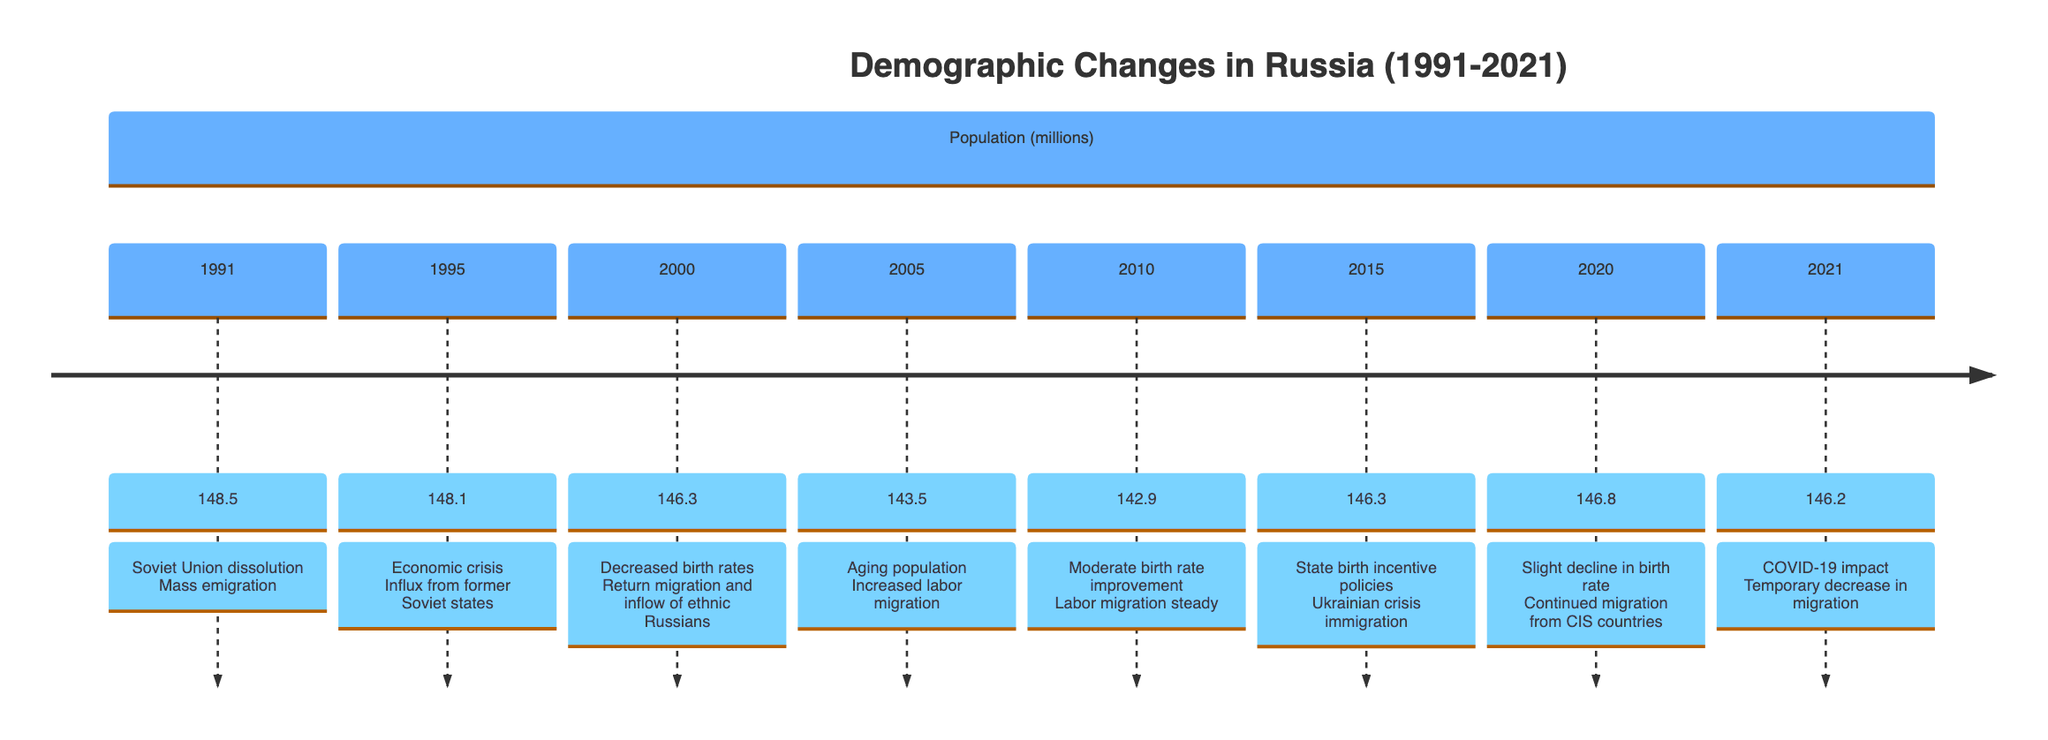What was the population of Russia in 1991? According to the diagram, the population of Russia in 1991 was marked at 148.5 million.
Answer: 148.5 million What significant event occurred in 1995? The diagram states that in 1995, the salient event was an economic crisis which led to an influx from former Soviet states, indicated alongside the population figure.
Answer: Economic crisis What was the population in 2005? The specific value listed for the population in 2005 is 143.5 million, as shown in the diagram.
Answer: 143.5 million How did the population change from 2000 to 2010? The population decreased from 146.3 million in 2000 to 142.9 million in 2010, indicating a decline over that decade. Calculating the difference shows a total decrease of 3.4 million.
Answer: Decreased by 3.4 million What were the population levels in 2015 and 2020? In 2015 the population was 146.3 million and in 2020 it rose slightly to 146.8 million, according to the respective points on the diagram.
Answer: 146.3 million and 146.8 million What was the effect of COVID-19 on migration in 2021? The diagram illustrates that in 2021, COVID-19 had an impact leading to a temporary decrease in migration, emphasizing a direct effect on demographic patterns that year.
Answer: Temporary decrease How did migration patterns change from 1995 to 2021? The diagram indicates a fluctuation in migration, with notable influx from former Soviet states in 1995, steady labor migration until 2010, an increase due to the Ukrainian crisis in 2015, and finally a temporary decrease in 2021 due to COVID-19. This overview indicates both growth and decline phases.
Answer: Fluctuation What policy was implemented in 2015 and what was its impact? The diagram notes that in 2015, state birth incentive policies were introduced, which likely contributed to maintaining or slightly increasing the population that year, despite other crises affecting migration.
Answer: State birth incentive policies What was the lowest population recorded from 1991 to 2021? The lowest population recorded in this timeline is 142.9 million in 2010, the data clearly reflects this value.
Answer: 142.9 million 